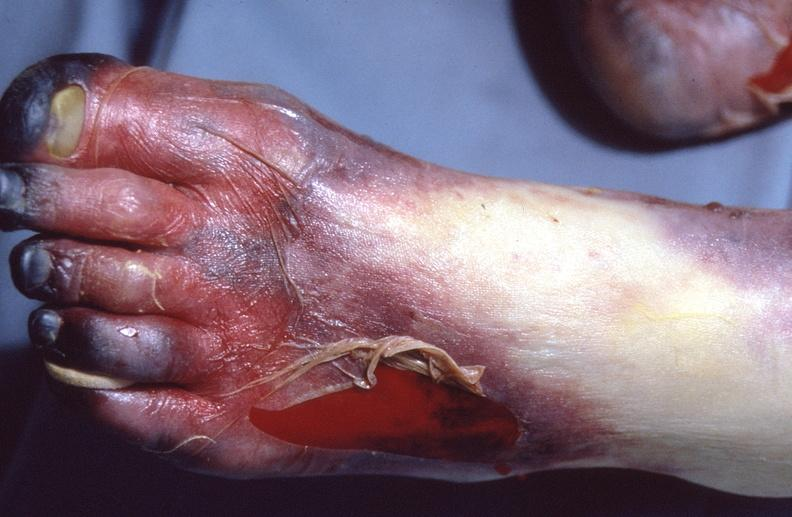where is this?
Answer the question using a single word or phrase. Skin 